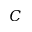<formula> <loc_0><loc_0><loc_500><loc_500>C</formula> 